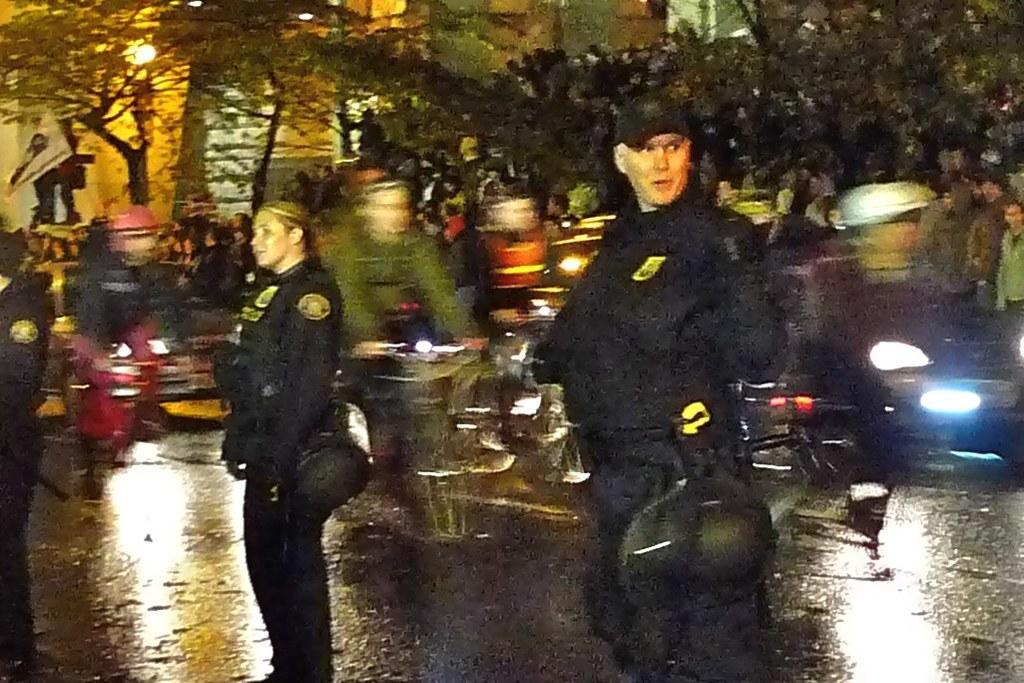Can you describe this image briefly? There are three persons wearing black dress are standing and there are few persons riding bicycles behind them and there are trees and a building in the background. 